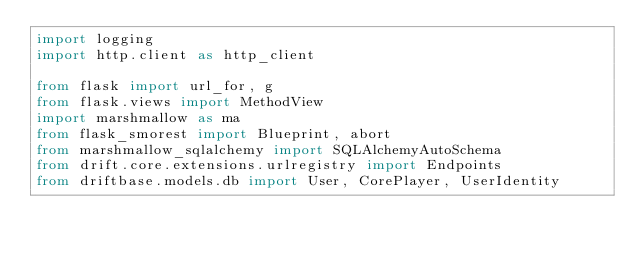<code> <loc_0><loc_0><loc_500><loc_500><_Python_>import logging
import http.client as http_client

from flask import url_for, g
from flask.views import MethodView
import marshmallow as ma
from flask_smorest import Blueprint, abort
from marshmallow_sqlalchemy import SQLAlchemyAutoSchema
from drift.core.extensions.urlregistry import Endpoints
from driftbase.models.db import User, CorePlayer, UserIdentity
</code> 